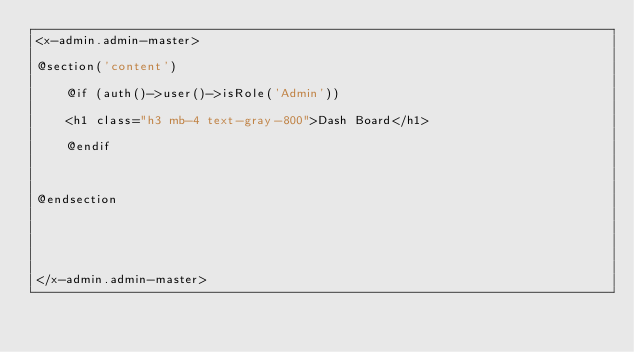Convert code to text. <code><loc_0><loc_0><loc_500><loc_500><_PHP_><x-admin.admin-master>

@section('content')

    @if (auth()->user()->isRole('Admin'))

    <h1 class="h3 mb-4 text-gray-800">Dash Board</h1>

    @endif



@endsection





</x-admin.admin-master>
</code> 